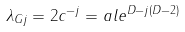<formula> <loc_0><loc_0><loc_500><loc_500>\lambda _ { G j } = 2 c ^ { - j } = a l e ^ { D - j ( D - 2 ) }</formula> 